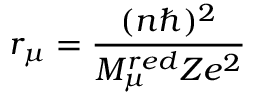<formula> <loc_0><loc_0><loc_500><loc_500>r _ { \mu } = \frac { ( n \hbar { ) } ^ { 2 } } { M _ { \mu } ^ { r e d } Z e ^ { 2 } }</formula> 